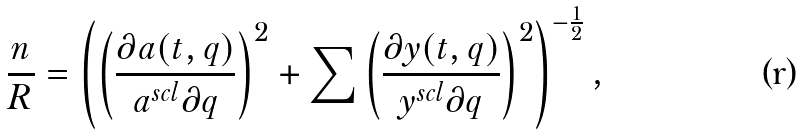<formula> <loc_0><loc_0><loc_500><loc_500>\frac { n } { R } = \left ( \left ( \frac { \partial a ( t , q ) } { a ^ { s c l } \partial q } \right ) ^ { 2 } + \sum \left ( \frac { \partial y ( t , q ) } { y ^ { s c l } \partial q } \right ) ^ { 2 } \right ) ^ { - \frac { 1 } { 2 } } ,</formula> 